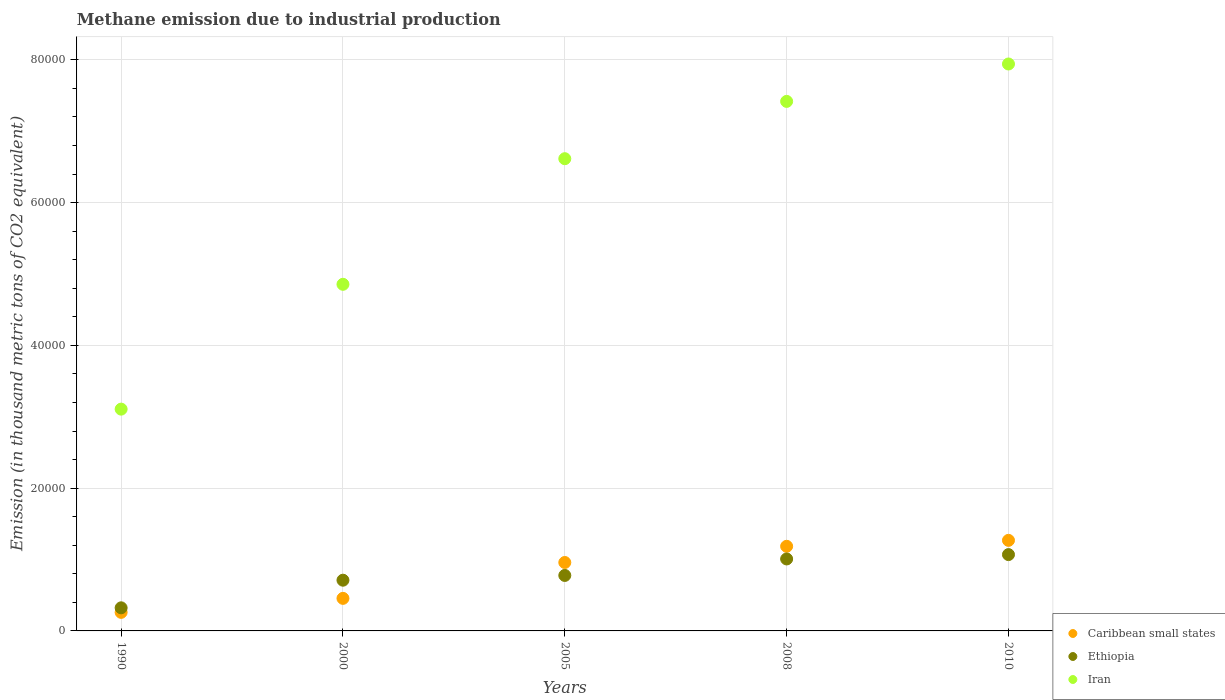How many different coloured dotlines are there?
Provide a short and direct response. 3. Is the number of dotlines equal to the number of legend labels?
Offer a very short reply. Yes. What is the amount of methane emitted in Caribbean small states in 2010?
Your response must be concise. 1.27e+04. Across all years, what is the maximum amount of methane emitted in Ethiopia?
Ensure brevity in your answer.  1.07e+04. Across all years, what is the minimum amount of methane emitted in Ethiopia?
Ensure brevity in your answer.  3236. What is the total amount of methane emitted in Iran in the graph?
Ensure brevity in your answer.  2.99e+05. What is the difference between the amount of methane emitted in Ethiopia in 1990 and that in 2005?
Your response must be concise. -4536.1. What is the difference between the amount of methane emitted in Ethiopia in 2000 and the amount of methane emitted in Iran in 2008?
Offer a terse response. -6.71e+04. What is the average amount of methane emitted in Iran per year?
Your answer should be compact. 5.99e+04. In the year 2005, what is the difference between the amount of methane emitted in Caribbean small states and amount of methane emitted in Ethiopia?
Give a very brief answer. 1814.5. In how many years, is the amount of methane emitted in Caribbean small states greater than 36000 thousand metric tons?
Your response must be concise. 0. What is the ratio of the amount of methane emitted in Ethiopia in 1990 to that in 2008?
Provide a succinct answer. 0.32. Is the amount of methane emitted in Iran in 2000 less than that in 2008?
Your answer should be compact. Yes. What is the difference between the highest and the second highest amount of methane emitted in Iran?
Give a very brief answer. 5239.8. What is the difference between the highest and the lowest amount of methane emitted in Caribbean small states?
Give a very brief answer. 1.01e+04. How many dotlines are there?
Make the answer very short. 3. How many years are there in the graph?
Provide a short and direct response. 5. Are the values on the major ticks of Y-axis written in scientific E-notation?
Offer a very short reply. No. Does the graph contain any zero values?
Keep it short and to the point. No. Where does the legend appear in the graph?
Provide a succinct answer. Bottom right. What is the title of the graph?
Keep it short and to the point. Methane emission due to industrial production. Does "Norway" appear as one of the legend labels in the graph?
Offer a very short reply. No. What is the label or title of the Y-axis?
Provide a short and direct response. Emission (in thousand metric tons of CO2 equivalent). What is the Emission (in thousand metric tons of CO2 equivalent) of Caribbean small states in 1990?
Offer a terse response. 2599.9. What is the Emission (in thousand metric tons of CO2 equivalent) of Ethiopia in 1990?
Your answer should be compact. 3236. What is the Emission (in thousand metric tons of CO2 equivalent) of Iran in 1990?
Your response must be concise. 3.11e+04. What is the Emission (in thousand metric tons of CO2 equivalent) in Caribbean small states in 2000?
Provide a short and direct response. 4560.6. What is the Emission (in thousand metric tons of CO2 equivalent) in Ethiopia in 2000?
Ensure brevity in your answer.  7106. What is the Emission (in thousand metric tons of CO2 equivalent) of Iran in 2000?
Your answer should be very brief. 4.86e+04. What is the Emission (in thousand metric tons of CO2 equivalent) in Caribbean small states in 2005?
Your response must be concise. 9586.6. What is the Emission (in thousand metric tons of CO2 equivalent) of Ethiopia in 2005?
Give a very brief answer. 7772.1. What is the Emission (in thousand metric tons of CO2 equivalent) in Iran in 2005?
Your answer should be very brief. 6.62e+04. What is the Emission (in thousand metric tons of CO2 equivalent) in Caribbean small states in 2008?
Your answer should be compact. 1.19e+04. What is the Emission (in thousand metric tons of CO2 equivalent) in Ethiopia in 2008?
Offer a very short reply. 1.01e+04. What is the Emission (in thousand metric tons of CO2 equivalent) in Iran in 2008?
Ensure brevity in your answer.  7.42e+04. What is the Emission (in thousand metric tons of CO2 equivalent) in Caribbean small states in 2010?
Offer a terse response. 1.27e+04. What is the Emission (in thousand metric tons of CO2 equivalent) of Ethiopia in 2010?
Provide a succinct answer. 1.07e+04. What is the Emission (in thousand metric tons of CO2 equivalent) of Iran in 2010?
Your response must be concise. 7.94e+04. Across all years, what is the maximum Emission (in thousand metric tons of CO2 equivalent) in Caribbean small states?
Provide a short and direct response. 1.27e+04. Across all years, what is the maximum Emission (in thousand metric tons of CO2 equivalent) in Ethiopia?
Your answer should be compact. 1.07e+04. Across all years, what is the maximum Emission (in thousand metric tons of CO2 equivalent) in Iran?
Ensure brevity in your answer.  7.94e+04. Across all years, what is the minimum Emission (in thousand metric tons of CO2 equivalent) in Caribbean small states?
Your answer should be very brief. 2599.9. Across all years, what is the minimum Emission (in thousand metric tons of CO2 equivalent) in Ethiopia?
Your answer should be compact. 3236. Across all years, what is the minimum Emission (in thousand metric tons of CO2 equivalent) of Iran?
Offer a very short reply. 3.11e+04. What is the total Emission (in thousand metric tons of CO2 equivalent) of Caribbean small states in the graph?
Offer a very short reply. 4.13e+04. What is the total Emission (in thousand metric tons of CO2 equivalent) of Ethiopia in the graph?
Provide a succinct answer. 3.89e+04. What is the total Emission (in thousand metric tons of CO2 equivalent) of Iran in the graph?
Your answer should be compact. 2.99e+05. What is the difference between the Emission (in thousand metric tons of CO2 equivalent) of Caribbean small states in 1990 and that in 2000?
Make the answer very short. -1960.7. What is the difference between the Emission (in thousand metric tons of CO2 equivalent) in Ethiopia in 1990 and that in 2000?
Your response must be concise. -3870. What is the difference between the Emission (in thousand metric tons of CO2 equivalent) in Iran in 1990 and that in 2000?
Your answer should be very brief. -1.75e+04. What is the difference between the Emission (in thousand metric tons of CO2 equivalent) in Caribbean small states in 1990 and that in 2005?
Provide a short and direct response. -6986.7. What is the difference between the Emission (in thousand metric tons of CO2 equivalent) of Ethiopia in 1990 and that in 2005?
Offer a very short reply. -4536.1. What is the difference between the Emission (in thousand metric tons of CO2 equivalent) of Iran in 1990 and that in 2005?
Give a very brief answer. -3.51e+04. What is the difference between the Emission (in thousand metric tons of CO2 equivalent) of Caribbean small states in 1990 and that in 2008?
Offer a very short reply. -9255.6. What is the difference between the Emission (in thousand metric tons of CO2 equivalent) in Ethiopia in 1990 and that in 2008?
Provide a succinct answer. -6846.3. What is the difference between the Emission (in thousand metric tons of CO2 equivalent) of Iran in 1990 and that in 2008?
Your answer should be compact. -4.31e+04. What is the difference between the Emission (in thousand metric tons of CO2 equivalent) of Caribbean small states in 1990 and that in 2010?
Keep it short and to the point. -1.01e+04. What is the difference between the Emission (in thousand metric tons of CO2 equivalent) in Ethiopia in 1990 and that in 2010?
Make the answer very short. -7457. What is the difference between the Emission (in thousand metric tons of CO2 equivalent) of Iran in 1990 and that in 2010?
Ensure brevity in your answer.  -4.84e+04. What is the difference between the Emission (in thousand metric tons of CO2 equivalent) in Caribbean small states in 2000 and that in 2005?
Provide a succinct answer. -5026. What is the difference between the Emission (in thousand metric tons of CO2 equivalent) in Ethiopia in 2000 and that in 2005?
Offer a very short reply. -666.1. What is the difference between the Emission (in thousand metric tons of CO2 equivalent) of Iran in 2000 and that in 2005?
Your answer should be very brief. -1.76e+04. What is the difference between the Emission (in thousand metric tons of CO2 equivalent) of Caribbean small states in 2000 and that in 2008?
Your response must be concise. -7294.9. What is the difference between the Emission (in thousand metric tons of CO2 equivalent) of Ethiopia in 2000 and that in 2008?
Give a very brief answer. -2976.3. What is the difference between the Emission (in thousand metric tons of CO2 equivalent) in Iran in 2000 and that in 2008?
Your answer should be compact. -2.56e+04. What is the difference between the Emission (in thousand metric tons of CO2 equivalent) in Caribbean small states in 2000 and that in 2010?
Provide a succinct answer. -8127.6. What is the difference between the Emission (in thousand metric tons of CO2 equivalent) in Ethiopia in 2000 and that in 2010?
Keep it short and to the point. -3587. What is the difference between the Emission (in thousand metric tons of CO2 equivalent) of Iran in 2000 and that in 2010?
Ensure brevity in your answer.  -3.09e+04. What is the difference between the Emission (in thousand metric tons of CO2 equivalent) in Caribbean small states in 2005 and that in 2008?
Your answer should be compact. -2268.9. What is the difference between the Emission (in thousand metric tons of CO2 equivalent) of Ethiopia in 2005 and that in 2008?
Make the answer very short. -2310.2. What is the difference between the Emission (in thousand metric tons of CO2 equivalent) in Iran in 2005 and that in 2008?
Make the answer very short. -8028.1. What is the difference between the Emission (in thousand metric tons of CO2 equivalent) in Caribbean small states in 2005 and that in 2010?
Offer a terse response. -3101.6. What is the difference between the Emission (in thousand metric tons of CO2 equivalent) of Ethiopia in 2005 and that in 2010?
Make the answer very short. -2920.9. What is the difference between the Emission (in thousand metric tons of CO2 equivalent) in Iran in 2005 and that in 2010?
Give a very brief answer. -1.33e+04. What is the difference between the Emission (in thousand metric tons of CO2 equivalent) in Caribbean small states in 2008 and that in 2010?
Provide a succinct answer. -832.7. What is the difference between the Emission (in thousand metric tons of CO2 equivalent) of Ethiopia in 2008 and that in 2010?
Keep it short and to the point. -610.7. What is the difference between the Emission (in thousand metric tons of CO2 equivalent) in Iran in 2008 and that in 2010?
Your response must be concise. -5239.8. What is the difference between the Emission (in thousand metric tons of CO2 equivalent) of Caribbean small states in 1990 and the Emission (in thousand metric tons of CO2 equivalent) of Ethiopia in 2000?
Make the answer very short. -4506.1. What is the difference between the Emission (in thousand metric tons of CO2 equivalent) in Caribbean small states in 1990 and the Emission (in thousand metric tons of CO2 equivalent) in Iran in 2000?
Keep it short and to the point. -4.60e+04. What is the difference between the Emission (in thousand metric tons of CO2 equivalent) in Ethiopia in 1990 and the Emission (in thousand metric tons of CO2 equivalent) in Iran in 2000?
Make the answer very short. -4.53e+04. What is the difference between the Emission (in thousand metric tons of CO2 equivalent) of Caribbean small states in 1990 and the Emission (in thousand metric tons of CO2 equivalent) of Ethiopia in 2005?
Your answer should be very brief. -5172.2. What is the difference between the Emission (in thousand metric tons of CO2 equivalent) in Caribbean small states in 1990 and the Emission (in thousand metric tons of CO2 equivalent) in Iran in 2005?
Your answer should be compact. -6.36e+04. What is the difference between the Emission (in thousand metric tons of CO2 equivalent) of Ethiopia in 1990 and the Emission (in thousand metric tons of CO2 equivalent) of Iran in 2005?
Offer a terse response. -6.29e+04. What is the difference between the Emission (in thousand metric tons of CO2 equivalent) in Caribbean small states in 1990 and the Emission (in thousand metric tons of CO2 equivalent) in Ethiopia in 2008?
Offer a terse response. -7482.4. What is the difference between the Emission (in thousand metric tons of CO2 equivalent) of Caribbean small states in 1990 and the Emission (in thousand metric tons of CO2 equivalent) of Iran in 2008?
Your answer should be compact. -7.16e+04. What is the difference between the Emission (in thousand metric tons of CO2 equivalent) of Ethiopia in 1990 and the Emission (in thousand metric tons of CO2 equivalent) of Iran in 2008?
Offer a terse response. -7.09e+04. What is the difference between the Emission (in thousand metric tons of CO2 equivalent) in Caribbean small states in 1990 and the Emission (in thousand metric tons of CO2 equivalent) in Ethiopia in 2010?
Offer a very short reply. -8093.1. What is the difference between the Emission (in thousand metric tons of CO2 equivalent) of Caribbean small states in 1990 and the Emission (in thousand metric tons of CO2 equivalent) of Iran in 2010?
Provide a short and direct response. -7.68e+04. What is the difference between the Emission (in thousand metric tons of CO2 equivalent) in Ethiopia in 1990 and the Emission (in thousand metric tons of CO2 equivalent) in Iran in 2010?
Your answer should be very brief. -7.62e+04. What is the difference between the Emission (in thousand metric tons of CO2 equivalent) of Caribbean small states in 2000 and the Emission (in thousand metric tons of CO2 equivalent) of Ethiopia in 2005?
Keep it short and to the point. -3211.5. What is the difference between the Emission (in thousand metric tons of CO2 equivalent) of Caribbean small states in 2000 and the Emission (in thousand metric tons of CO2 equivalent) of Iran in 2005?
Provide a short and direct response. -6.16e+04. What is the difference between the Emission (in thousand metric tons of CO2 equivalent) in Ethiopia in 2000 and the Emission (in thousand metric tons of CO2 equivalent) in Iran in 2005?
Your answer should be compact. -5.91e+04. What is the difference between the Emission (in thousand metric tons of CO2 equivalent) of Caribbean small states in 2000 and the Emission (in thousand metric tons of CO2 equivalent) of Ethiopia in 2008?
Offer a terse response. -5521.7. What is the difference between the Emission (in thousand metric tons of CO2 equivalent) of Caribbean small states in 2000 and the Emission (in thousand metric tons of CO2 equivalent) of Iran in 2008?
Your answer should be very brief. -6.96e+04. What is the difference between the Emission (in thousand metric tons of CO2 equivalent) in Ethiopia in 2000 and the Emission (in thousand metric tons of CO2 equivalent) in Iran in 2008?
Provide a succinct answer. -6.71e+04. What is the difference between the Emission (in thousand metric tons of CO2 equivalent) of Caribbean small states in 2000 and the Emission (in thousand metric tons of CO2 equivalent) of Ethiopia in 2010?
Provide a succinct answer. -6132.4. What is the difference between the Emission (in thousand metric tons of CO2 equivalent) in Caribbean small states in 2000 and the Emission (in thousand metric tons of CO2 equivalent) in Iran in 2010?
Your answer should be compact. -7.49e+04. What is the difference between the Emission (in thousand metric tons of CO2 equivalent) in Ethiopia in 2000 and the Emission (in thousand metric tons of CO2 equivalent) in Iran in 2010?
Your answer should be compact. -7.23e+04. What is the difference between the Emission (in thousand metric tons of CO2 equivalent) of Caribbean small states in 2005 and the Emission (in thousand metric tons of CO2 equivalent) of Ethiopia in 2008?
Offer a terse response. -495.7. What is the difference between the Emission (in thousand metric tons of CO2 equivalent) in Caribbean small states in 2005 and the Emission (in thousand metric tons of CO2 equivalent) in Iran in 2008?
Offer a very short reply. -6.46e+04. What is the difference between the Emission (in thousand metric tons of CO2 equivalent) in Ethiopia in 2005 and the Emission (in thousand metric tons of CO2 equivalent) in Iran in 2008?
Ensure brevity in your answer.  -6.64e+04. What is the difference between the Emission (in thousand metric tons of CO2 equivalent) in Caribbean small states in 2005 and the Emission (in thousand metric tons of CO2 equivalent) in Ethiopia in 2010?
Provide a short and direct response. -1106.4. What is the difference between the Emission (in thousand metric tons of CO2 equivalent) in Caribbean small states in 2005 and the Emission (in thousand metric tons of CO2 equivalent) in Iran in 2010?
Keep it short and to the point. -6.98e+04. What is the difference between the Emission (in thousand metric tons of CO2 equivalent) in Ethiopia in 2005 and the Emission (in thousand metric tons of CO2 equivalent) in Iran in 2010?
Your answer should be compact. -7.17e+04. What is the difference between the Emission (in thousand metric tons of CO2 equivalent) in Caribbean small states in 2008 and the Emission (in thousand metric tons of CO2 equivalent) in Ethiopia in 2010?
Make the answer very short. 1162.5. What is the difference between the Emission (in thousand metric tons of CO2 equivalent) in Caribbean small states in 2008 and the Emission (in thousand metric tons of CO2 equivalent) in Iran in 2010?
Your answer should be compact. -6.76e+04. What is the difference between the Emission (in thousand metric tons of CO2 equivalent) of Ethiopia in 2008 and the Emission (in thousand metric tons of CO2 equivalent) of Iran in 2010?
Ensure brevity in your answer.  -6.93e+04. What is the average Emission (in thousand metric tons of CO2 equivalent) of Caribbean small states per year?
Your answer should be compact. 8258.16. What is the average Emission (in thousand metric tons of CO2 equivalent) of Ethiopia per year?
Your answer should be compact. 7777.88. What is the average Emission (in thousand metric tons of CO2 equivalent) in Iran per year?
Ensure brevity in your answer.  5.99e+04. In the year 1990, what is the difference between the Emission (in thousand metric tons of CO2 equivalent) of Caribbean small states and Emission (in thousand metric tons of CO2 equivalent) of Ethiopia?
Offer a very short reply. -636.1. In the year 1990, what is the difference between the Emission (in thousand metric tons of CO2 equivalent) of Caribbean small states and Emission (in thousand metric tons of CO2 equivalent) of Iran?
Your answer should be compact. -2.85e+04. In the year 1990, what is the difference between the Emission (in thousand metric tons of CO2 equivalent) in Ethiopia and Emission (in thousand metric tons of CO2 equivalent) in Iran?
Your answer should be compact. -2.78e+04. In the year 2000, what is the difference between the Emission (in thousand metric tons of CO2 equivalent) in Caribbean small states and Emission (in thousand metric tons of CO2 equivalent) in Ethiopia?
Ensure brevity in your answer.  -2545.4. In the year 2000, what is the difference between the Emission (in thousand metric tons of CO2 equivalent) in Caribbean small states and Emission (in thousand metric tons of CO2 equivalent) in Iran?
Your response must be concise. -4.40e+04. In the year 2000, what is the difference between the Emission (in thousand metric tons of CO2 equivalent) in Ethiopia and Emission (in thousand metric tons of CO2 equivalent) in Iran?
Make the answer very short. -4.15e+04. In the year 2005, what is the difference between the Emission (in thousand metric tons of CO2 equivalent) of Caribbean small states and Emission (in thousand metric tons of CO2 equivalent) of Ethiopia?
Make the answer very short. 1814.5. In the year 2005, what is the difference between the Emission (in thousand metric tons of CO2 equivalent) in Caribbean small states and Emission (in thousand metric tons of CO2 equivalent) in Iran?
Keep it short and to the point. -5.66e+04. In the year 2005, what is the difference between the Emission (in thousand metric tons of CO2 equivalent) in Ethiopia and Emission (in thousand metric tons of CO2 equivalent) in Iran?
Your response must be concise. -5.84e+04. In the year 2008, what is the difference between the Emission (in thousand metric tons of CO2 equivalent) of Caribbean small states and Emission (in thousand metric tons of CO2 equivalent) of Ethiopia?
Your answer should be very brief. 1773.2. In the year 2008, what is the difference between the Emission (in thousand metric tons of CO2 equivalent) of Caribbean small states and Emission (in thousand metric tons of CO2 equivalent) of Iran?
Ensure brevity in your answer.  -6.23e+04. In the year 2008, what is the difference between the Emission (in thousand metric tons of CO2 equivalent) of Ethiopia and Emission (in thousand metric tons of CO2 equivalent) of Iran?
Make the answer very short. -6.41e+04. In the year 2010, what is the difference between the Emission (in thousand metric tons of CO2 equivalent) in Caribbean small states and Emission (in thousand metric tons of CO2 equivalent) in Ethiopia?
Make the answer very short. 1995.2. In the year 2010, what is the difference between the Emission (in thousand metric tons of CO2 equivalent) in Caribbean small states and Emission (in thousand metric tons of CO2 equivalent) in Iran?
Your response must be concise. -6.67e+04. In the year 2010, what is the difference between the Emission (in thousand metric tons of CO2 equivalent) of Ethiopia and Emission (in thousand metric tons of CO2 equivalent) of Iran?
Offer a very short reply. -6.87e+04. What is the ratio of the Emission (in thousand metric tons of CO2 equivalent) of Caribbean small states in 1990 to that in 2000?
Provide a short and direct response. 0.57. What is the ratio of the Emission (in thousand metric tons of CO2 equivalent) of Ethiopia in 1990 to that in 2000?
Offer a very short reply. 0.46. What is the ratio of the Emission (in thousand metric tons of CO2 equivalent) in Iran in 1990 to that in 2000?
Offer a terse response. 0.64. What is the ratio of the Emission (in thousand metric tons of CO2 equivalent) in Caribbean small states in 1990 to that in 2005?
Offer a very short reply. 0.27. What is the ratio of the Emission (in thousand metric tons of CO2 equivalent) of Ethiopia in 1990 to that in 2005?
Ensure brevity in your answer.  0.42. What is the ratio of the Emission (in thousand metric tons of CO2 equivalent) of Iran in 1990 to that in 2005?
Your answer should be compact. 0.47. What is the ratio of the Emission (in thousand metric tons of CO2 equivalent) in Caribbean small states in 1990 to that in 2008?
Make the answer very short. 0.22. What is the ratio of the Emission (in thousand metric tons of CO2 equivalent) of Ethiopia in 1990 to that in 2008?
Keep it short and to the point. 0.32. What is the ratio of the Emission (in thousand metric tons of CO2 equivalent) of Iran in 1990 to that in 2008?
Give a very brief answer. 0.42. What is the ratio of the Emission (in thousand metric tons of CO2 equivalent) in Caribbean small states in 1990 to that in 2010?
Offer a terse response. 0.2. What is the ratio of the Emission (in thousand metric tons of CO2 equivalent) of Ethiopia in 1990 to that in 2010?
Your response must be concise. 0.3. What is the ratio of the Emission (in thousand metric tons of CO2 equivalent) in Iran in 1990 to that in 2010?
Ensure brevity in your answer.  0.39. What is the ratio of the Emission (in thousand metric tons of CO2 equivalent) in Caribbean small states in 2000 to that in 2005?
Your answer should be very brief. 0.48. What is the ratio of the Emission (in thousand metric tons of CO2 equivalent) in Ethiopia in 2000 to that in 2005?
Provide a short and direct response. 0.91. What is the ratio of the Emission (in thousand metric tons of CO2 equivalent) in Iran in 2000 to that in 2005?
Your answer should be very brief. 0.73. What is the ratio of the Emission (in thousand metric tons of CO2 equivalent) in Caribbean small states in 2000 to that in 2008?
Ensure brevity in your answer.  0.38. What is the ratio of the Emission (in thousand metric tons of CO2 equivalent) in Ethiopia in 2000 to that in 2008?
Keep it short and to the point. 0.7. What is the ratio of the Emission (in thousand metric tons of CO2 equivalent) of Iran in 2000 to that in 2008?
Offer a very short reply. 0.65. What is the ratio of the Emission (in thousand metric tons of CO2 equivalent) in Caribbean small states in 2000 to that in 2010?
Offer a terse response. 0.36. What is the ratio of the Emission (in thousand metric tons of CO2 equivalent) of Ethiopia in 2000 to that in 2010?
Provide a succinct answer. 0.66. What is the ratio of the Emission (in thousand metric tons of CO2 equivalent) in Iran in 2000 to that in 2010?
Your answer should be very brief. 0.61. What is the ratio of the Emission (in thousand metric tons of CO2 equivalent) in Caribbean small states in 2005 to that in 2008?
Make the answer very short. 0.81. What is the ratio of the Emission (in thousand metric tons of CO2 equivalent) of Ethiopia in 2005 to that in 2008?
Provide a succinct answer. 0.77. What is the ratio of the Emission (in thousand metric tons of CO2 equivalent) of Iran in 2005 to that in 2008?
Ensure brevity in your answer.  0.89. What is the ratio of the Emission (in thousand metric tons of CO2 equivalent) in Caribbean small states in 2005 to that in 2010?
Your answer should be very brief. 0.76. What is the ratio of the Emission (in thousand metric tons of CO2 equivalent) in Ethiopia in 2005 to that in 2010?
Keep it short and to the point. 0.73. What is the ratio of the Emission (in thousand metric tons of CO2 equivalent) in Iran in 2005 to that in 2010?
Offer a very short reply. 0.83. What is the ratio of the Emission (in thousand metric tons of CO2 equivalent) in Caribbean small states in 2008 to that in 2010?
Give a very brief answer. 0.93. What is the ratio of the Emission (in thousand metric tons of CO2 equivalent) in Ethiopia in 2008 to that in 2010?
Your answer should be very brief. 0.94. What is the ratio of the Emission (in thousand metric tons of CO2 equivalent) in Iran in 2008 to that in 2010?
Give a very brief answer. 0.93. What is the difference between the highest and the second highest Emission (in thousand metric tons of CO2 equivalent) in Caribbean small states?
Offer a very short reply. 832.7. What is the difference between the highest and the second highest Emission (in thousand metric tons of CO2 equivalent) in Ethiopia?
Your answer should be compact. 610.7. What is the difference between the highest and the second highest Emission (in thousand metric tons of CO2 equivalent) in Iran?
Offer a terse response. 5239.8. What is the difference between the highest and the lowest Emission (in thousand metric tons of CO2 equivalent) of Caribbean small states?
Keep it short and to the point. 1.01e+04. What is the difference between the highest and the lowest Emission (in thousand metric tons of CO2 equivalent) of Ethiopia?
Provide a short and direct response. 7457. What is the difference between the highest and the lowest Emission (in thousand metric tons of CO2 equivalent) in Iran?
Your answer should be compact. 4.84e+04. 